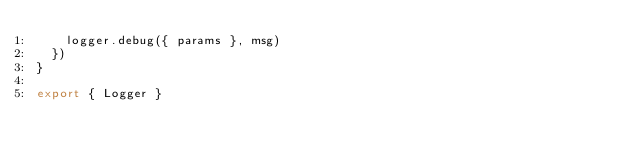<code> <loc_0><loc_0><loc_500><loc_500><_TypeScript_>    logger.debug({ params }, msg)
  })
}

export { Logger }
</code> 